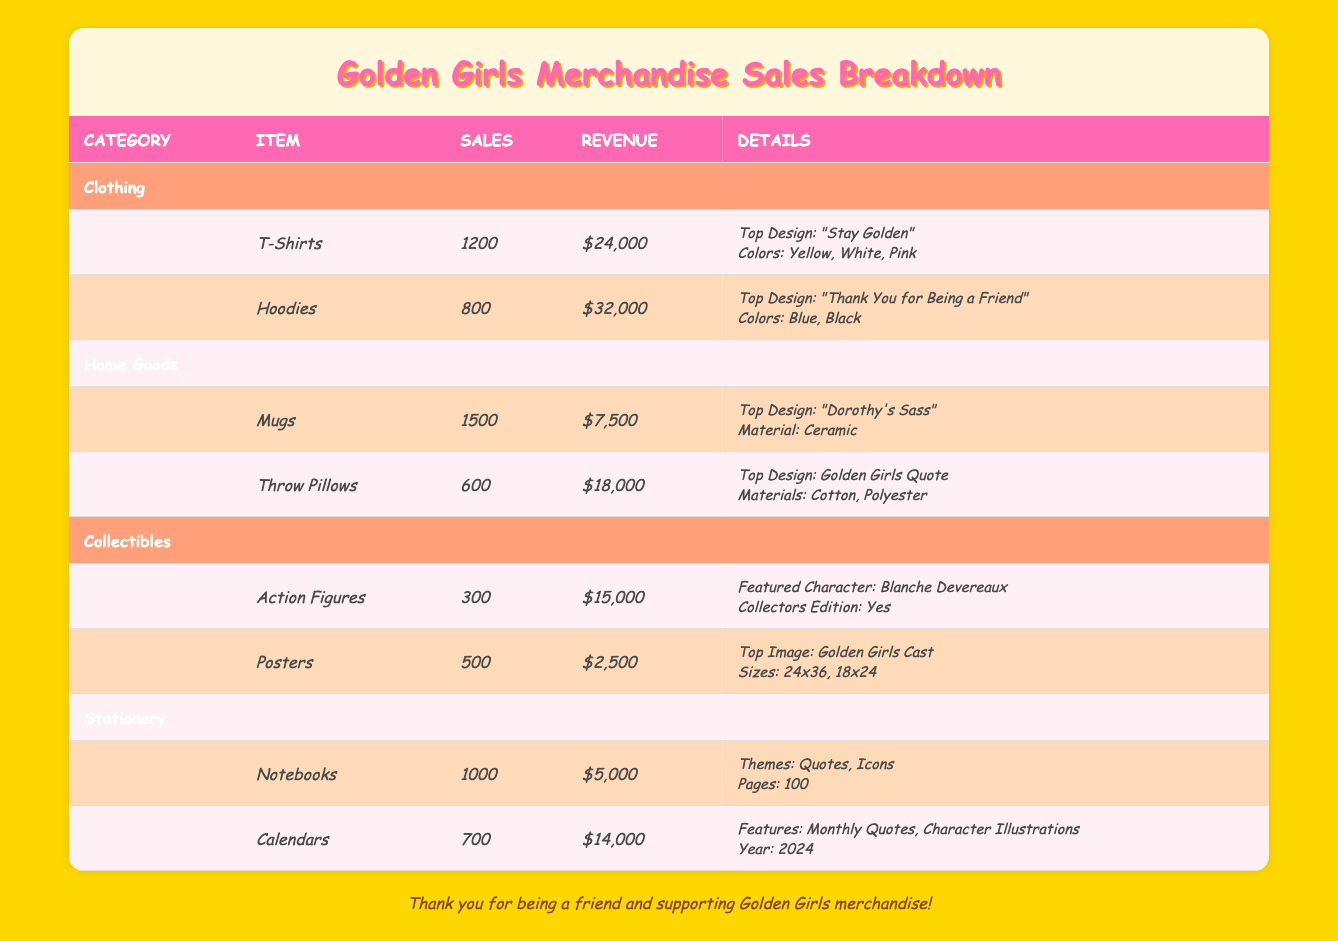What is the total revenue generated from Clothing merchandise? To find the total revenue from Clothing, we need to sum the revenue of all clothing items listed. T-Shirts generate $24,000 + Hoodies generate $32,000, so total revenue is $24,000 + $32,000 = $56,000.
Answer: $56,000 How many units of Throw Pillows were sold? Referring to the table, under the Home Goods category, the entry for Throw Pillows shows that 600 units were sold.
Answer: 600 What is the top design of the Mugs? Looking at the details for Mugs in the Home Goods category, the top design listed is "Dorothy's Sass."
Answer: Dorothy's Sass Did any Action Figures have a featured character? The table indicates that Action Figures featured "Blanche Devereaux" as the character, so yes, there was a featured character.
Answer: Yes What is the average revenue of the Stationery items? To calculate the average revenue of Stationery items, first sum the revenues: Notebooks ($5,000) + Calendars ($14,000) = $19,000. Then, divide by the number of Stationery items, which is 2. So, $19,000 / 2 = $9,500.
Answer: $9,500 Which item has the highest number of units sold? Checking the sales figures in the table indicates that Mugs have the highest sales at 1,500 units, compared to other items.
Answer: Mugs How many different colors are available for Hoodies? The Hoodies item lists two colors available: Blue and Black, thus there are two different colors.
Answer: 2 What is the total number of items sold across all categories? To find the total number of items sold, add the sales figures from all items: T-Shirts (1,200) + Hoodies (800) + Mugs (1,500) + Throw Pillows (600) + Action Figures (300) + Posters (500) + Notebooks (1,000) + Calendars (700) = 5,600.
Answer: 5,600 What percentage of total sales come from Collectibles? First, calculate total sales: 1,200 + 800 + 1,500 + 600 + 300 + 500 + 1,000 + 700 = 5,600. Now, sales from Collectibles are 300 (Action Figures) + 500 (Posters) = 800. The percentage is (800 / 5600) * 100 = 14.29%.
Answer: 14.29% 